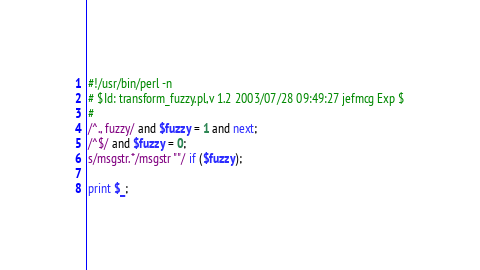<code> <loc_0><loc_0><loc_500><loc_500><_Perl_>#!/usr/bin/perl -n
# $Id: transform_fuzzy.pl,v 1.2 2003/07/28 09:49:27 jefmcg Exp $
#
/^., fuzzy/ and $fuzzy = 1 and next;
/^$/ and $fuzzy = 0;
s/msgstr.*/msgstr ""/ if ($fuzzy);

print $_;

</code> 